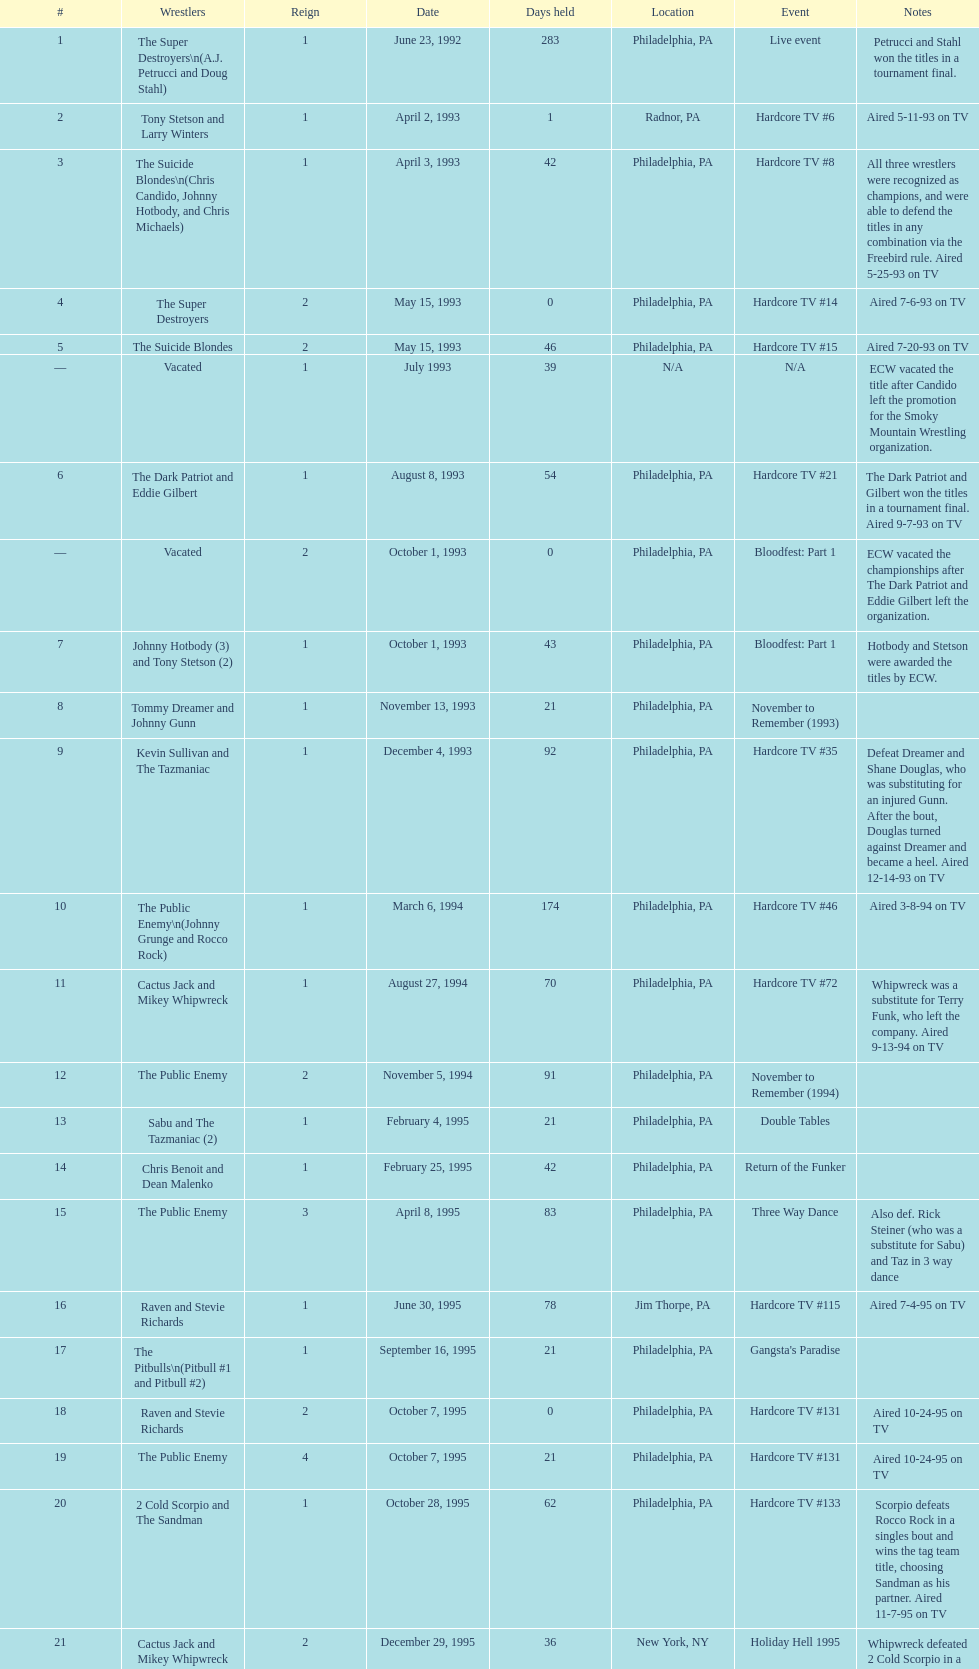Who held the title before the public enemy regained it on april 8th, 1995? Chris Benoit and Dean Malenko. 